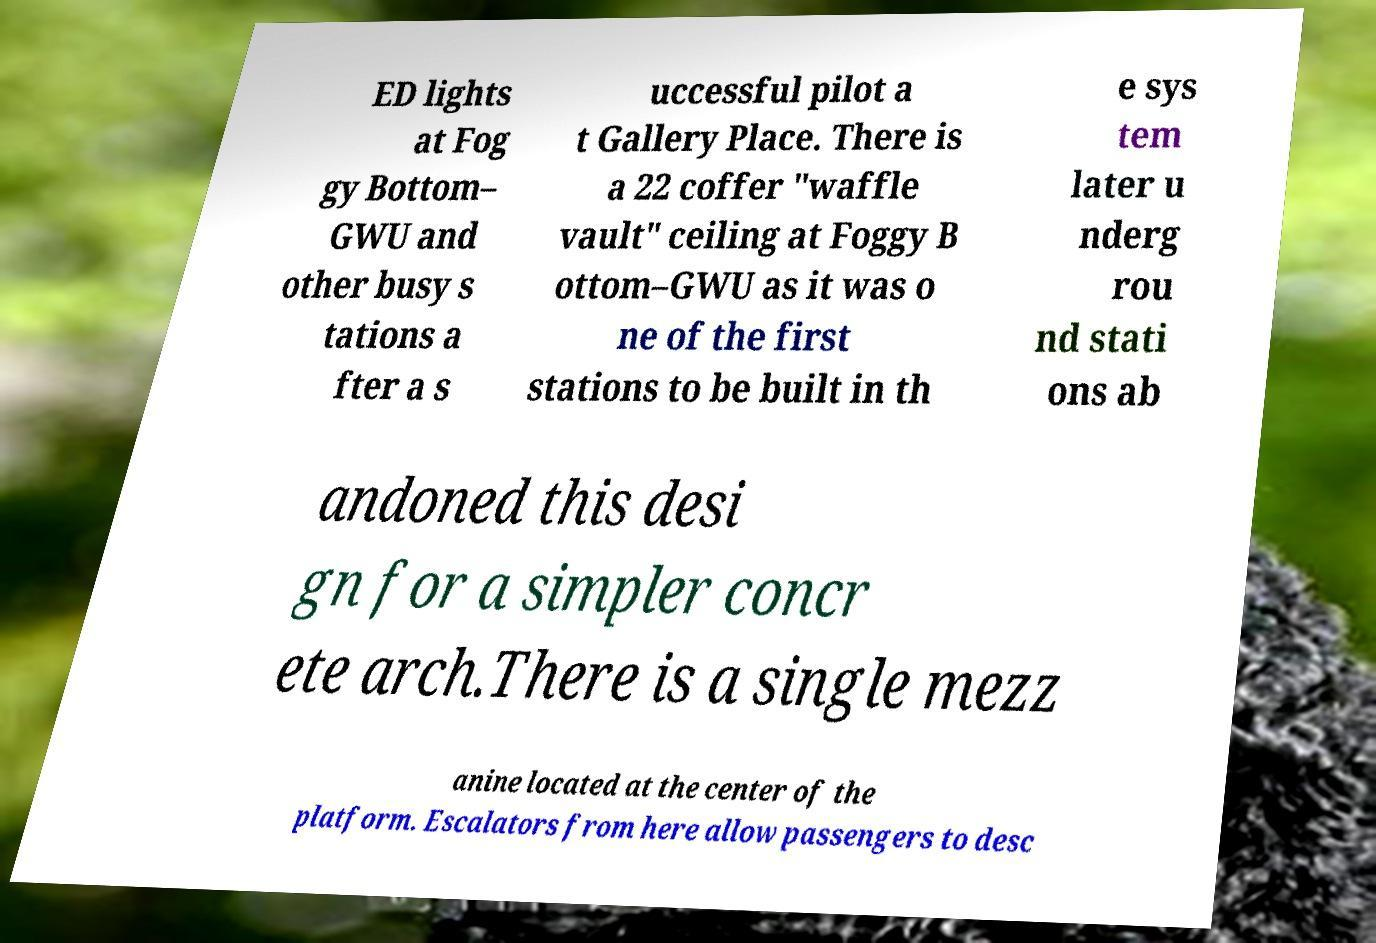Could you extract and type out the text from this image? ED lights at Fog gy Bottom– GWU and other busy s tations a fter a s uccessful pilot a t Gallery Place. There is a 22 coffer "waffle vault" ceiling at Foggy B ottom–GWU as it was o ne of the first stations to be built in th e sys tem later u nderg rou nd stati ons ab andoned this desi gn for a simpler concr ete arch.There is a single mezz anine located at the center of the platform. Escalators from here allow passengers to desc 